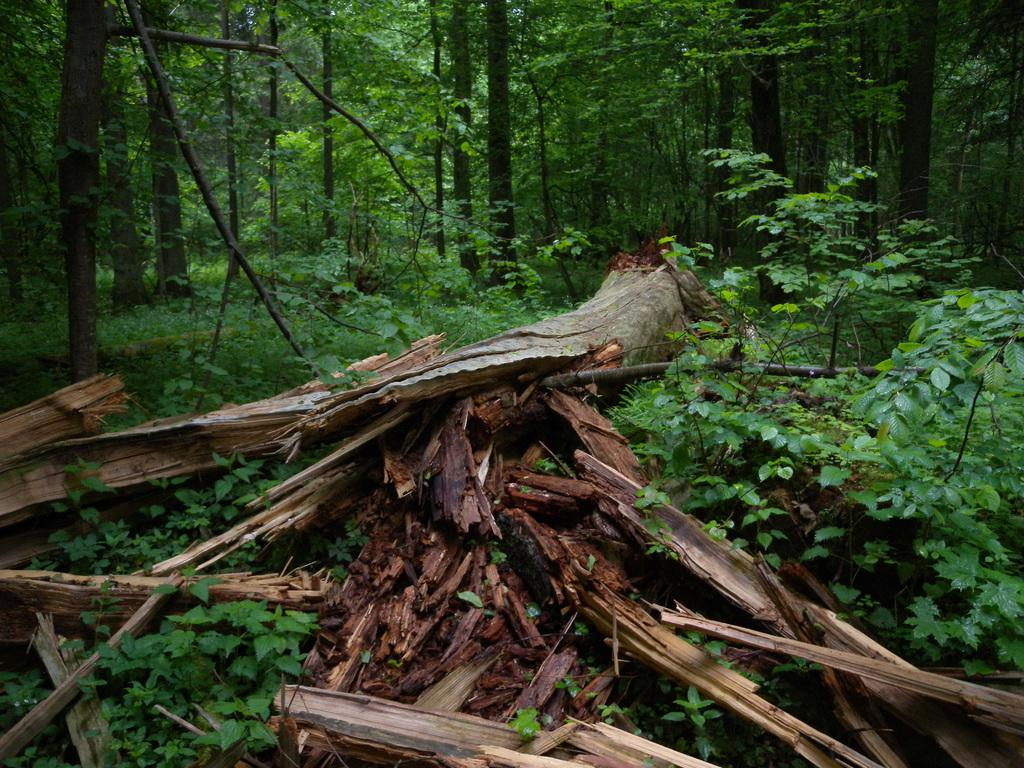What is located at the bottom of the image? There are plants and wooden sticks at the bottom of the image. Can you describe the vegetation in the image? The plants and trees are visible in the image. What is visible in the background of the image? There are trees in the background of the image. What type of tooth can be seen in the image? There is no tooth present in the image. Where is the basin located in the image? There is no basin present in the image. 